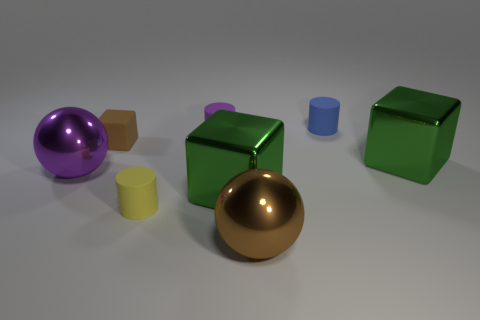Subtract all small blue cylinders. How many cylinders are left? 2 Add 1 brown things. How many objects exist? 9 Subtract 2 cylinders. How many cylinders are left? 1 Subtract all purple cylinders. How many cylinders are left? 2 Subtract all cylinders. How many objects are left? 5 Subtract all green cubes. Subtract all blue cylinders. How many cubes are left? 1 Subtract all red balls. How many green cubes are left? 2 Subtract all large green objects. Subtract all purple rubber objects. How many objects are left? 5 Add 6 big metallic spheres. How many big metallic spheres are left? 8 Add 8 brown metallic balls. How many brown metallic balls exist? 9 